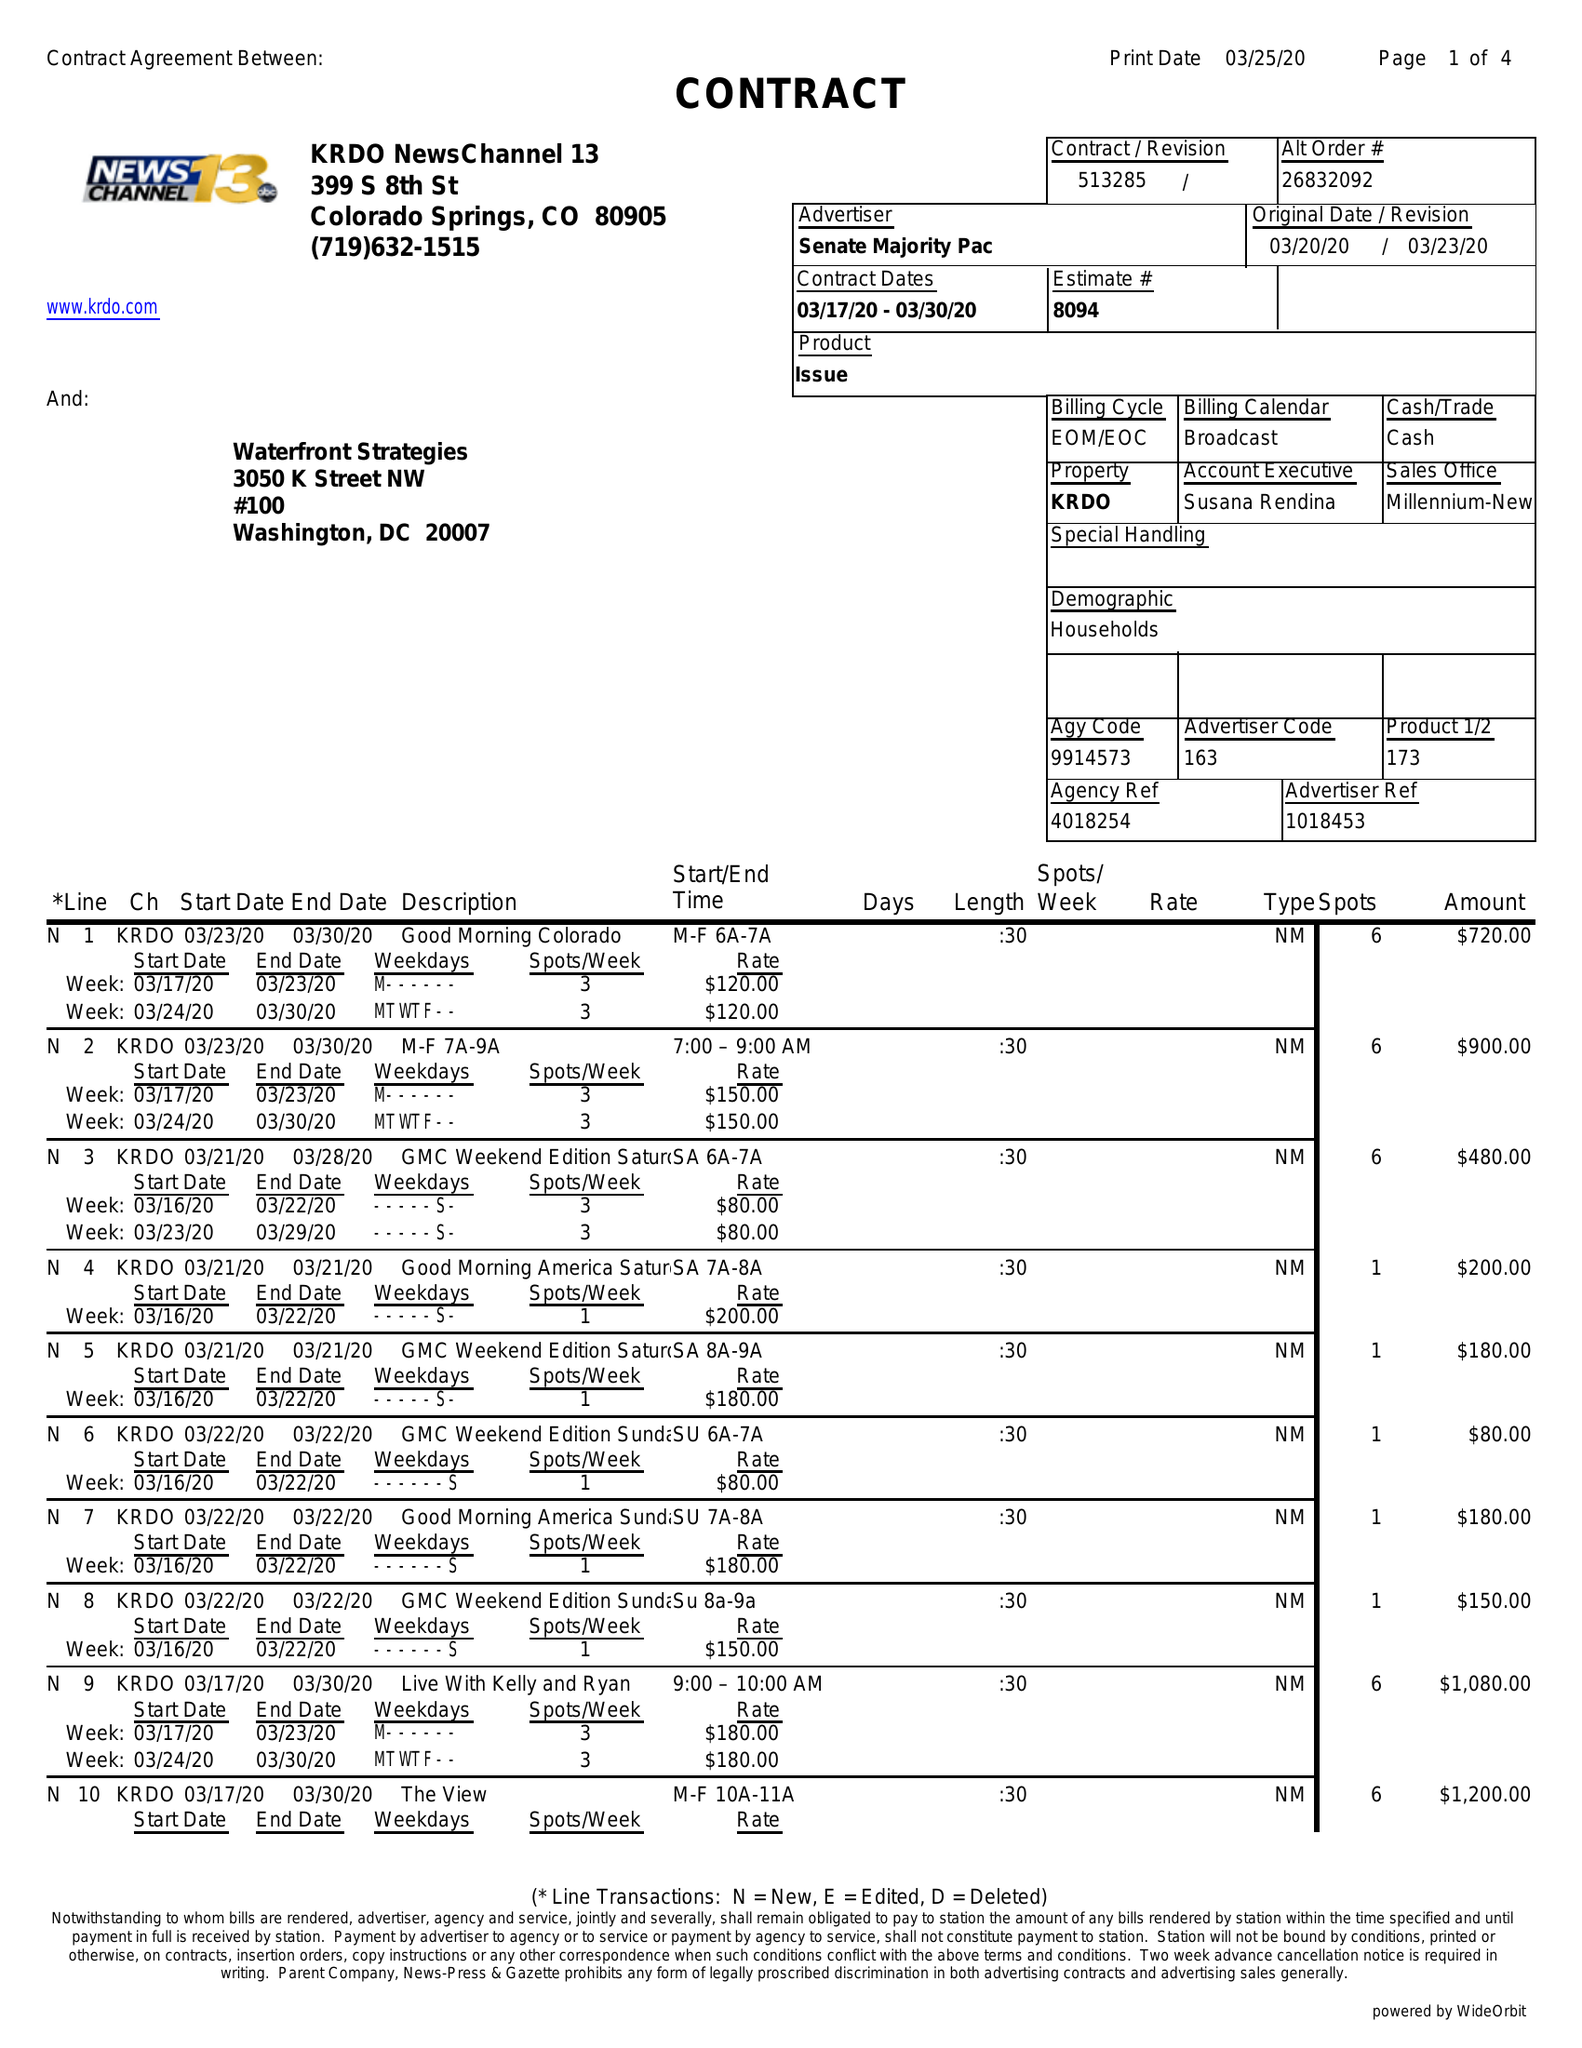What is the value for the flight_to?
Answer the question using a single word or phrase. 03/30/20 